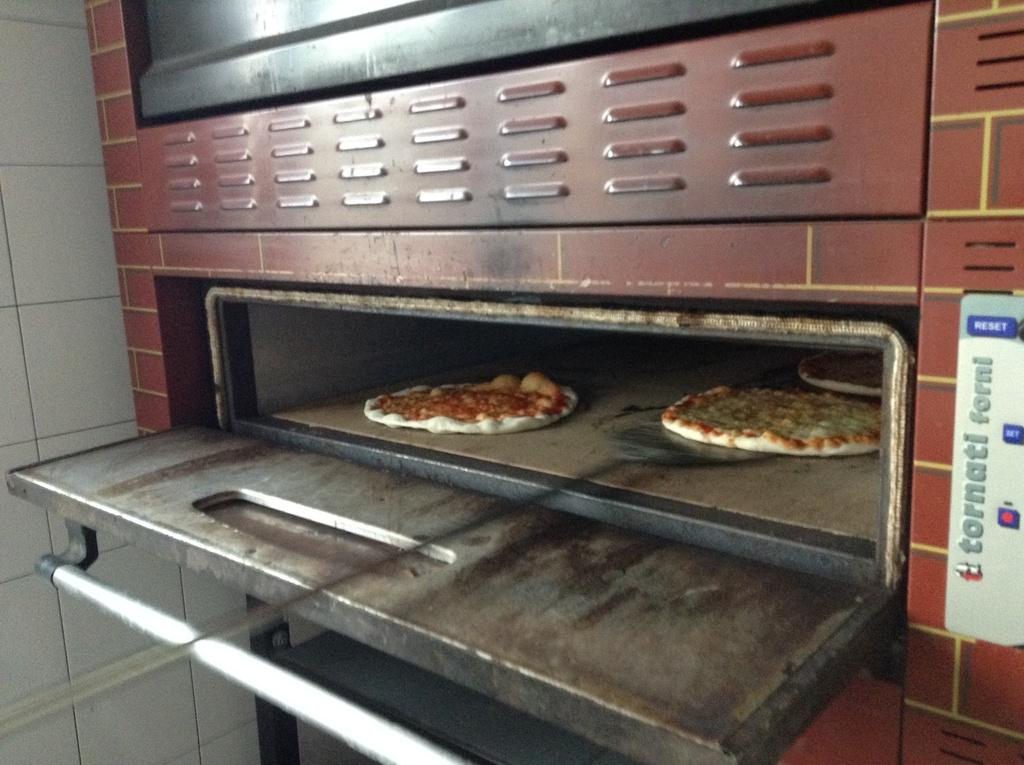<image>
Give a short and clear explanation of the subsequent image. A Tornati Forni commercial oven with pizzas in it. 